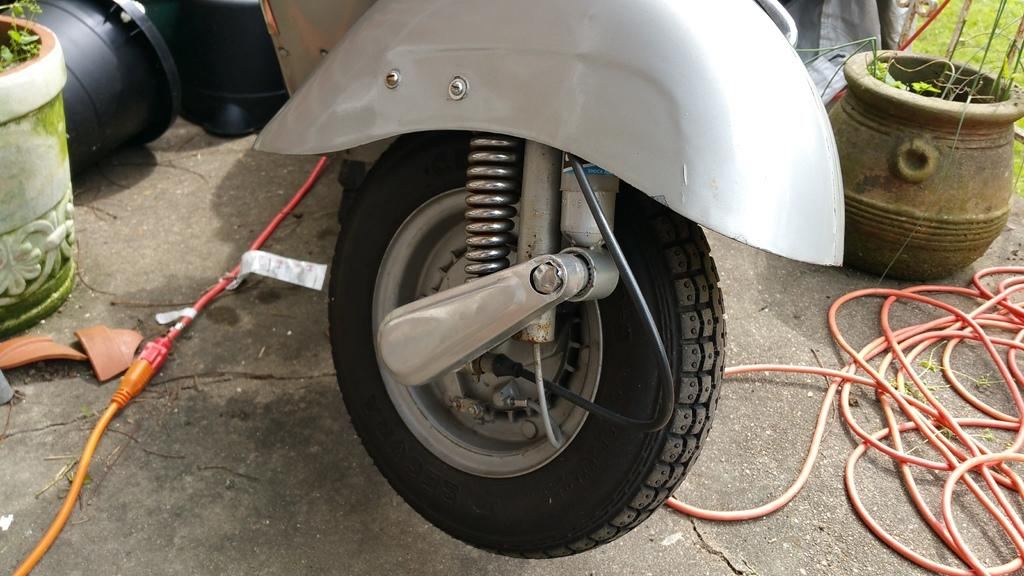What type of motor vehicle is on the floor in the image? The facts do not specify the type of motor vehicle, only that there is one on the floor. What else can be seen in the image besides the motor vehicle? There are pipelines and flower pots visible in the image. What is the ground made of in the image? The presence of grass suggests that the ground is made of grass. What type of punishment is being administered to the flower pots in the image? There is no punishment being administered to the flower pots in the image; they are simply flower pots. What musical instrument is being played by the grass in the image? There is no musical instrument being played by the grass in the image; it is simply grass. 